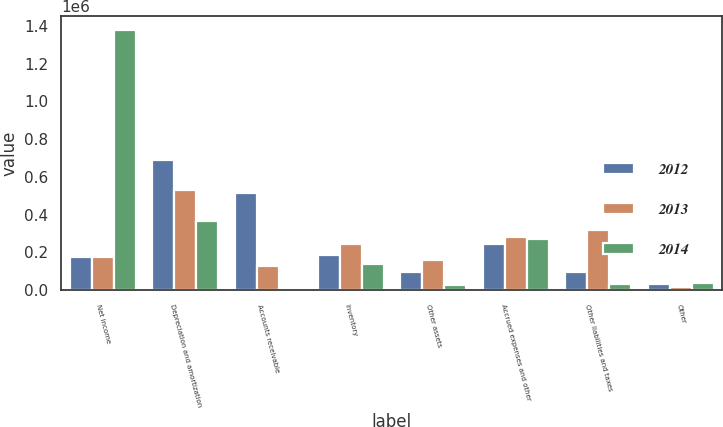Convert chart to OTSL. <chart><loc_0><loc_0><loc_500><loc_500><stacked_bar_chart><ecel><fcel>Net income<fcel>Depreciation and amortization<fcel>Accounts receivable<fcel>Inventory<fcel>Other assets<fcel>Accrued expenses and other<fcel>Other liabilities and taxes<fcel>Other<nl><fcel>2012<fcel>173052<fcel>688150<fcel>512389<fcel>185917<fcel>94514<fcel>244378<fcel>94779<fcel>30697<nl><fcel>2013<fcel>173052<fcel>531740<fcel>126753<fcel>243960<fcel>160188<fcel>284049<fcel>318512<fcel>15733<nl><fcel>2014<fcel>1.38003e+06<fcel>365648<fcel>3571<fcel>140309<fcel>27347<fcel>273372<fcel>34112<fcel>39671<nl></chart> 